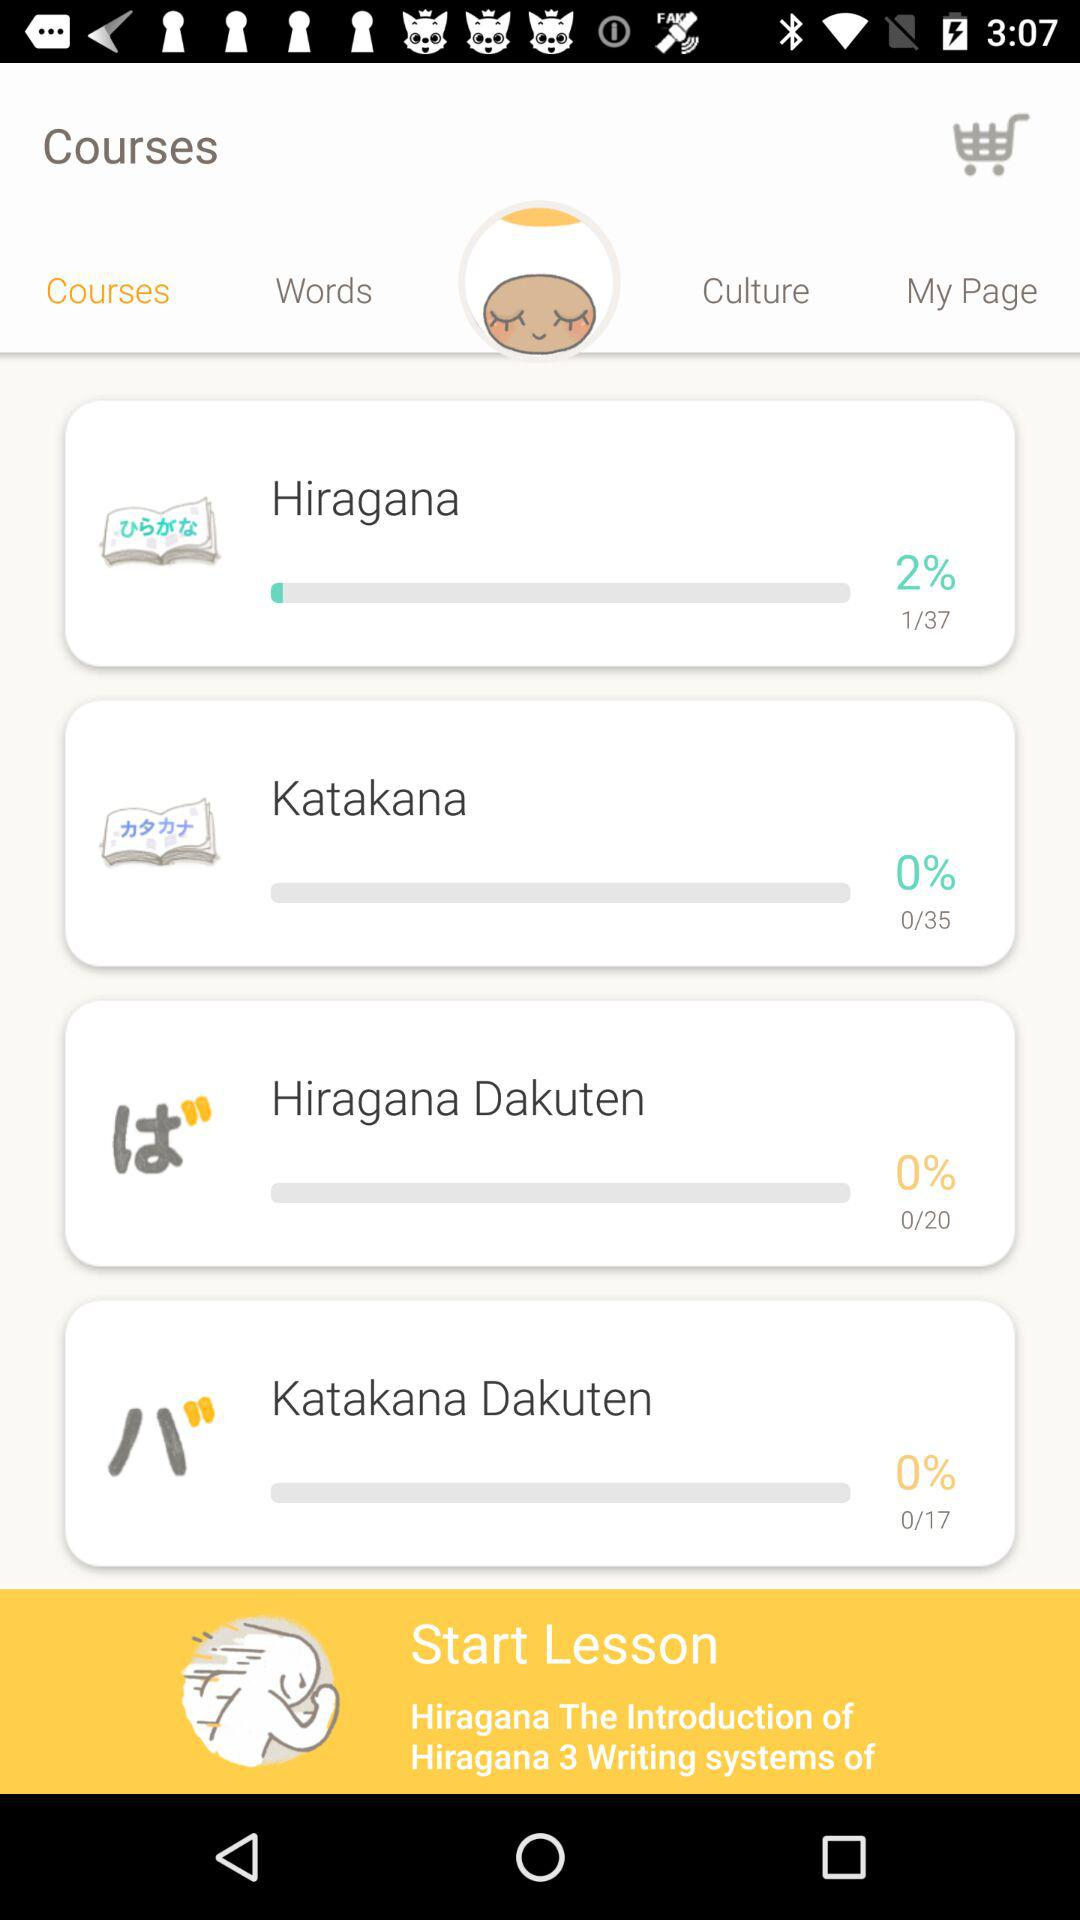How many pages are there in "Katakana" course? There are 9 pages. 